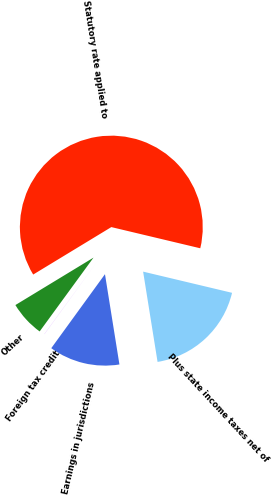Convert chart to OTSL. <chart><loc_0><loc_0><loc_500><loc_500><pie_chart><fcel>Statutory rate applied to<fcel>Plus state income taxes net of<fcel>Earnings in jurisdictions<fcel>Foreign tax credit<fcel>Other<nl><fcel>62.41%<fcel>18.75%<fcel>12.52%<fcel>0.04%<fcel>6.28%<nl></chart> 